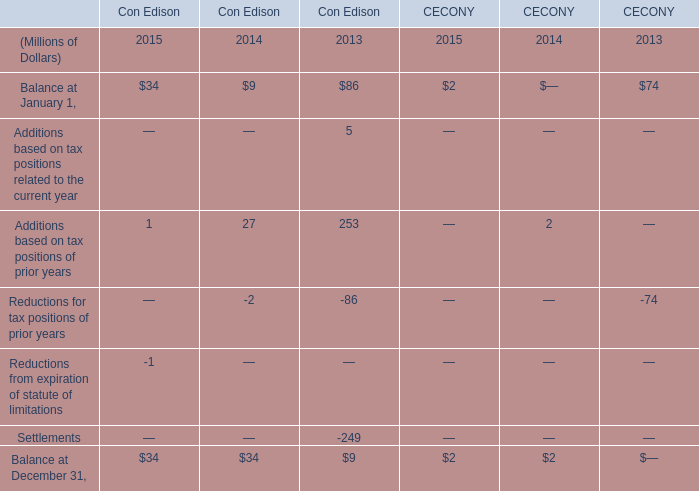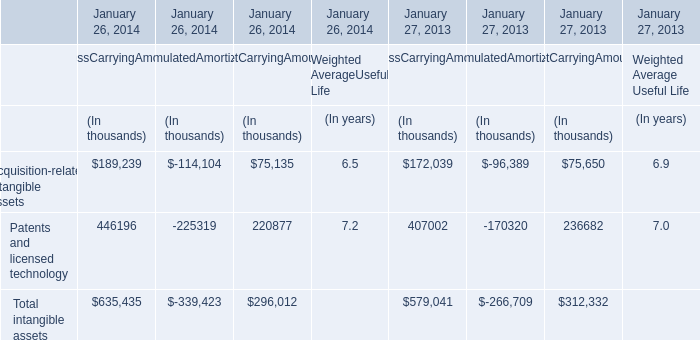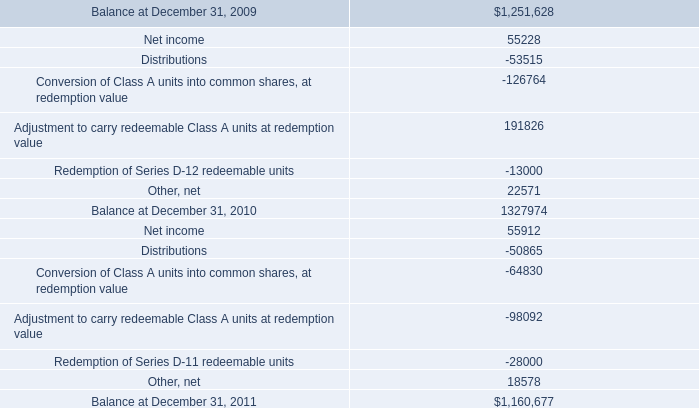What's the average of Additions based on tax positions of prior years of Con Edison in 2015, 2014, and 2013? (in million) 
Computations: (((1 + 27) + 253) / 3)
Answer: 93.66667. 